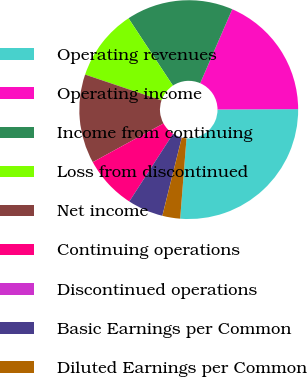Convert chart. <chart><loc_0><loc_0><loc_500><loc_500><pie_chart><fcel>Operating revenues<fcel>Operating income<fcel>Income from continuing<fcel>Loss from discontinued<fcel>Net income<fcel>Continuing operations<fcel>Discontinued operations<fcel>Basic Earnings per Common<fcel>Diluted Earnings per Common<nl><fcel>26.32%<fcel>18.42%<fcel>15.79%<fcel>10.53%<fcel>13.16%<fcel>7.89%<fcel>0.0%<fcel>5.26%<fcel>2.63%<nl></chart> 